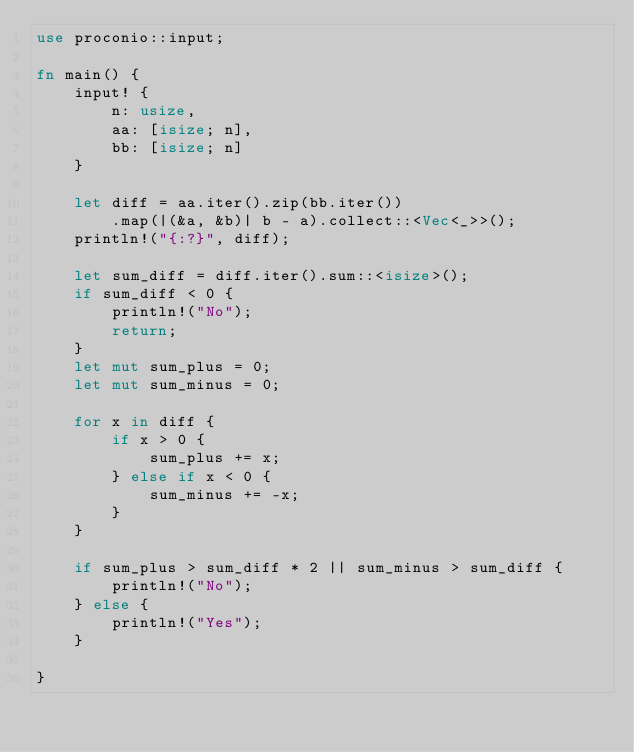<code> <loc_0><loc_0><loc_500><loc_500><_Rust_>use proconio::input;

fn main() {
    input! {
        n: usize,
        aa: [isize; n],
        bb: [isize; n]
    }

    let diff = aa.iter().zip(bb.iter())
        .map(|(&a, &b)| b - a).collect::<Vec<_>>();
    println!("{:?}", diff);
    
    let sum_diff = diff.iter().sum::<isize>();
    if sum_diff < 0 {
        println!("No");
        return;
    }
    let mut sum_plus = 0;
    let mut sum_minus = 0;

    for x in diff {
        if x > 0 {
            sum_plus += x;
        } else if x < 0 {
            sum_minus += -x;
        }
    }

    if sum_plus > sum_diff * 2 || sum_minus > sum_diff {
        println!("No");
    } else {
        println!("Yes");
    }
    
}
</code> 